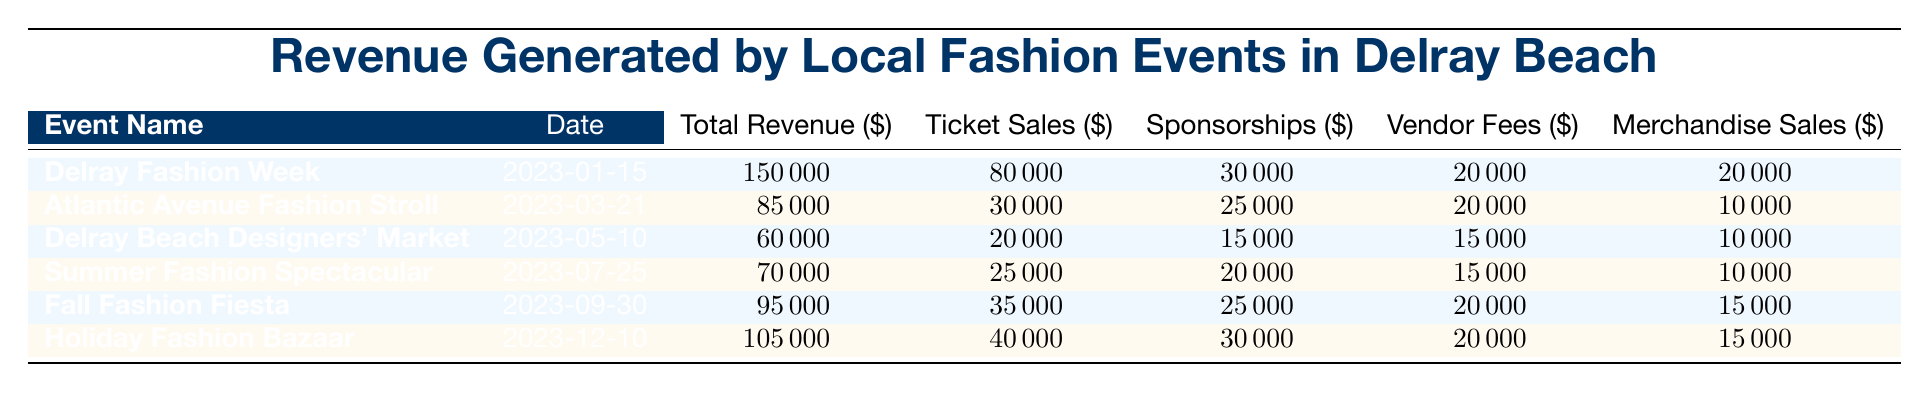What is the total revenue generated by the Delray Fashion Week? The total revenue for Delray Fashion Week is listed in the table under the "Total Revenue" column as 150000.
Answer: 150000 What event had the highest ticket sales? By checking the "Ticket Sales" column, Delray Fashion Week shows the highest value of 80000.
Answer: Delray Fashion Week Which event generated revenue through merchandise sales? Every event in the table has a merchandise sales value. For instance, Delray Fashion Week has 20000, Atlantic Avenue Fashion Stroll has 10000, and so on. Thus, all events generated some revenue through merchandise sales.
Answer: Yes What is the average sponsorship revenue across all events? First, I will sum the sponsorship revenues: 30000 + 25000 + 15000 + 20000 + 25000 + 30000 = 145000. Next, I divide by the number of events (6): 145000 / 6 = 24166.67.
Answer: 24166.67 Did the Holiday Fashion Bazaar generate more revenue than the Summer Fashion Spectacular? The total revenue for Holiday Fashion Bazaar is 105000 and for Summer Fashion Spectacular it is 70000. Since 105000 is greater than 70000, the statement is true.
Answer: Yes How much total revenue was generated from vendor fees across all events? Adding up the vendor fees gives: 20000 + 20000 + 15000 + 15000 + 20000 + 20000 = 110000. This total represents all vendor revenue combined.
Answer: 110000 What percentage of the total revenue for the Atlantic Avenue Fashion Stroll comes from ticket sales? The total revenue for the event is 85000, and ticket sales are 30000. Thus, the percentage is (30000 / 85000) * 100 = 35.29%.
Answer: 35.29% Which event had the least total revenue? By reviewing the "Total Revenue" column, Delray Beach Designers' Market has the lowest total revenue listed as 60000.
Answer: Delray Beach Designers' Market What is the difference in total revenue between the Holiday Fashion Bazaar and the Fall Fashion Fiesta? The total revenue for Holiday Fashion Bazaar is 105000, while for Fall Fashion Fiesta it is 95000. The difference is calculated as 105000 - 95000 = 10000.
Answer: 10000 